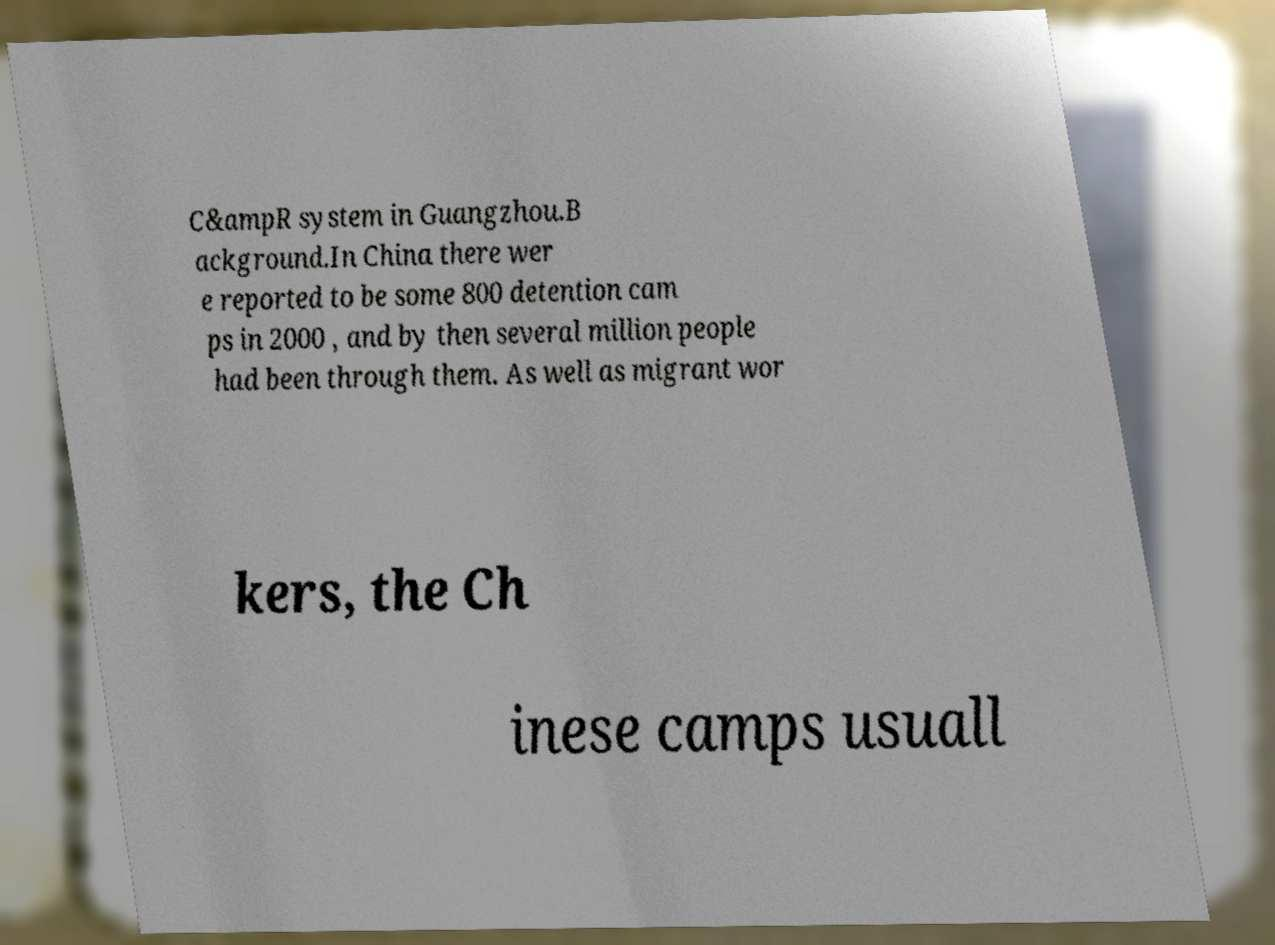Can you accurately transcribe the text from the provided image for me? C&ampR system in Guangzhou.B ackground.In China there wer e reported to be some 800 detention cam ps in 2000 , and by then several million people had been through them. As well as migrant wor kers, the Ch inese camps usuall 